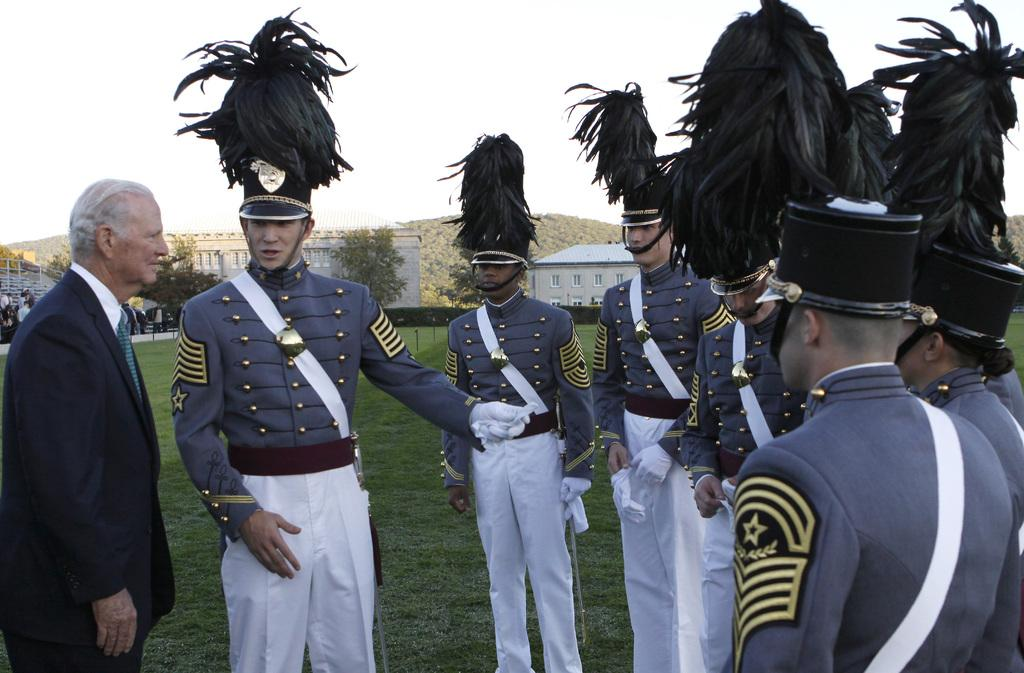What are the people in the image doing? The group of people in the image are standing on the ground. What can be seen on the buildings in the image? The buildings in the image have windows. What type of vegetation is visible in the image? There are trees visible in the image. What is visible in the background of the image? The sky is visible in the background of the image. How many servants are visible in the image? There are no servants present in the image. What type of health benefits can be gained from the trees in the image? The image does not provide information about the health benefits of the trees; it only shows their presence. 